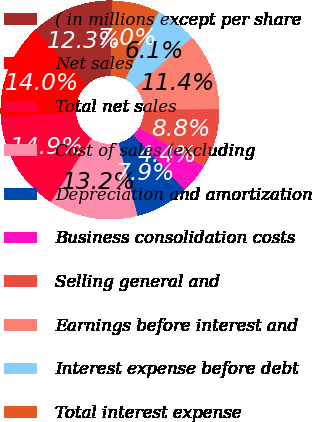Convert chart to OTSL. <chart><loc_0><loc_0><loc_500><loc_500><pie_chart><fcel>( in millions except per share<fcel>Net sales<fcel>Total net sales<fcel>Cost of sales (excluding<fcel>Depreciation and amortization<fcel>Business consolidation costs<fcel>Selling general and<fcel>Earnings before interest and<fcel>Interest expense before debt<fcel>Total interest expense<nl><fcel>12.28%<fcel>14.03%<fcel>14.91%<fcel>13.16%<fcel>7.89%<fcel>4.39%<fcel>8.77%<fcel>11.4%<fcel>6.14%<fcel>7.02%<nl></chart> 